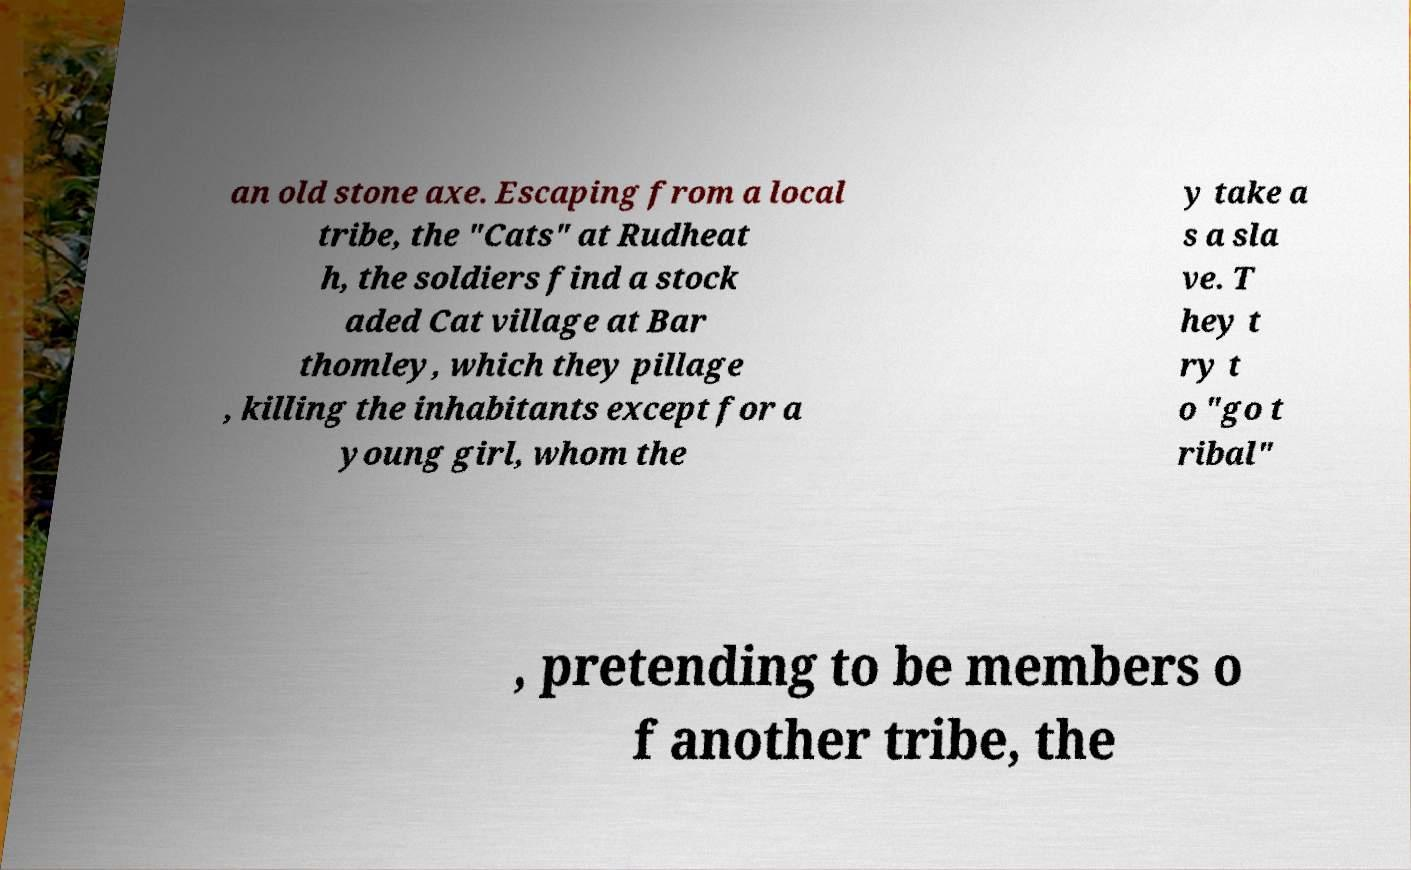Please read and relay the text visible in this image. What does it say? an old stone axe. Escaping from a local tribe, the "Cats" at Rudheat h, the soldiers find a stock aded Cat village at Bar thomley, which they pillage , killing the inhabitants except for a young girl, whom the y take a s a sla ve. T hey t ry t o "go t ribal" , pretending to be members o f another tribe, the 